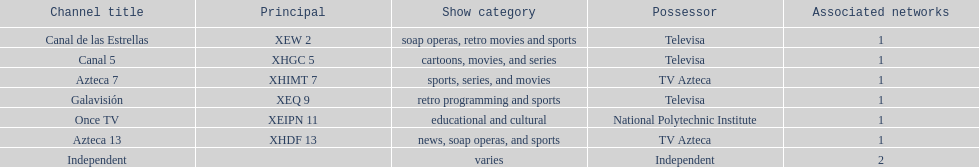How many networks does tv azteca own? 2. 